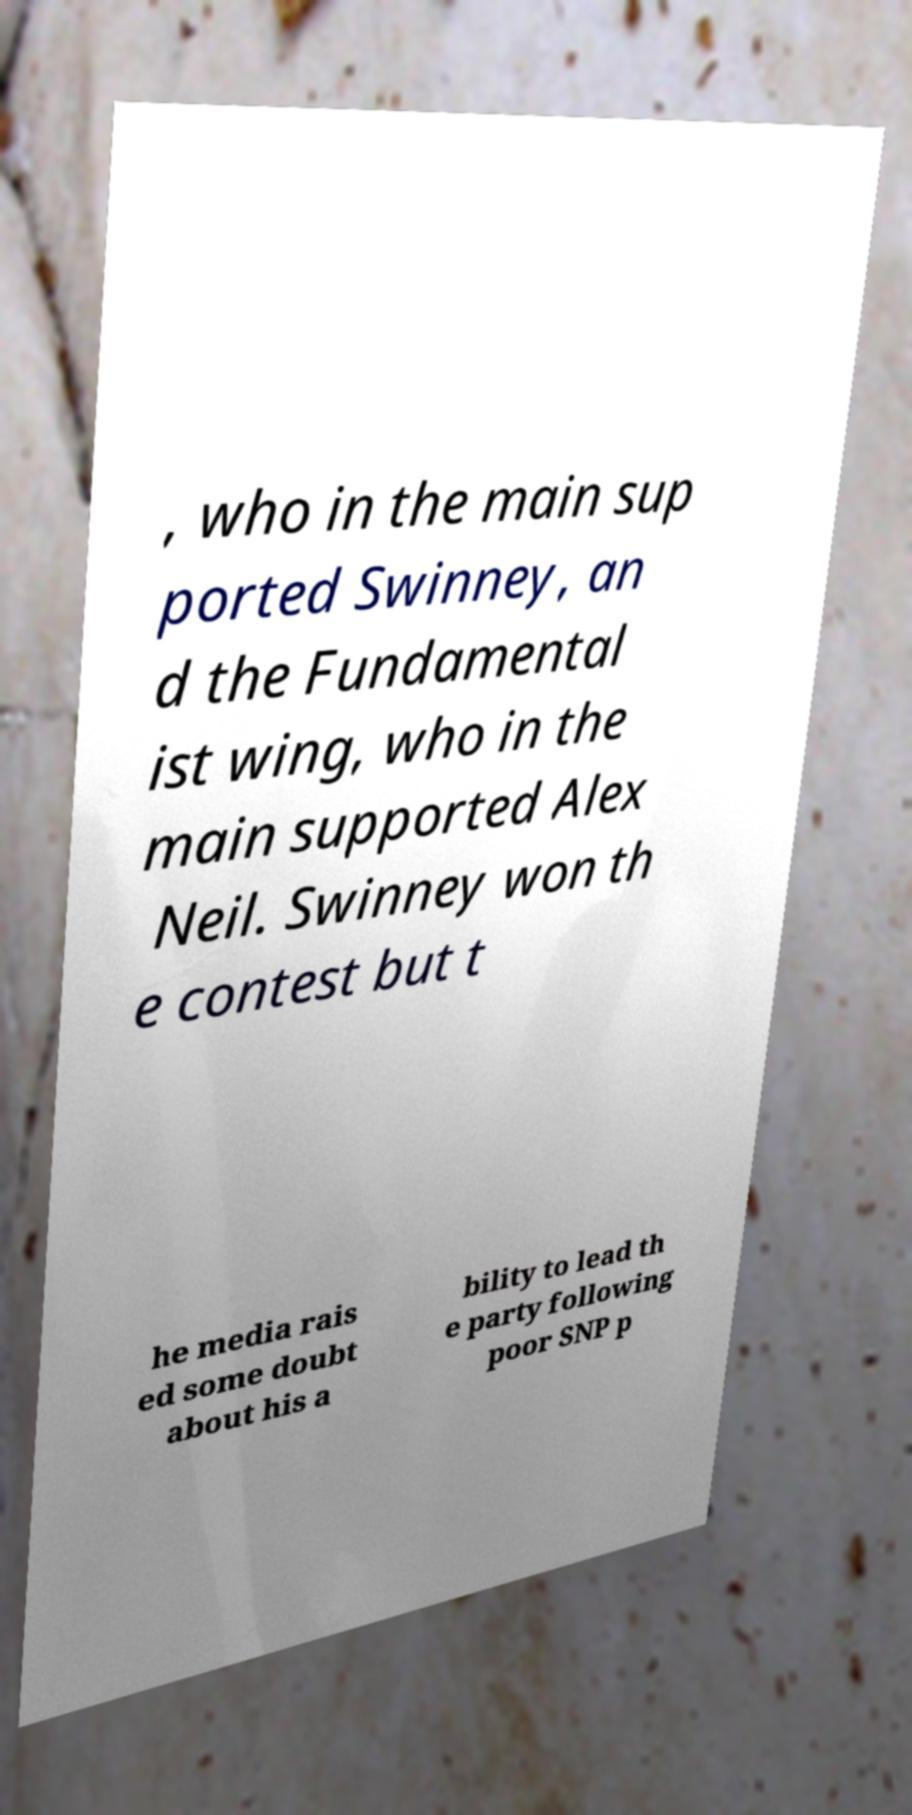What messages or text are displayed in this image? I need them in a readable, typed format. , who in the main sup ported Swinney, an d the Fundamental ist wing, who in the main supported Alex Neil. Swinney won th e contest but t he media rais ed some doubt about his a bility to lead th e party following poor SNP p 